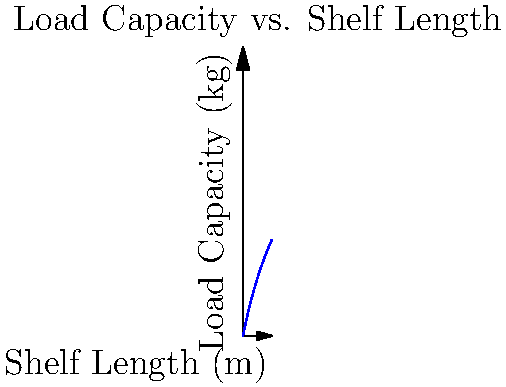Given the graph showing the relationship between shelf length and load capacity for coffee bean storage, what is the maximum load capacity (in kg) that can be safely supported by a shelf that is 4 meters long? To solve this problem, we need to follow these steps:

1. Understand the graph: The graph shows the relationship between shelf length (x-axis) and load capacity (y-axis).

2. Identify the function: The graph represents the function $f(x) = \frac{50x}{x+10}$, where x is the shelf length in meters and f(x) is the load capacity in kg.

3. Calculate the load capacity for a 4-meter shelf:
   $f(4) = \frac{50 * 4}{4 + 10} = \frac{200}{14} \approx 14.29$ kg

4. Round to the nearest whole number: 14 kg

This calculation shows that a 4-meter long shelf can safely support a maximum load of approximately 14 kg of coffee beans.
Answer: 14 kg 